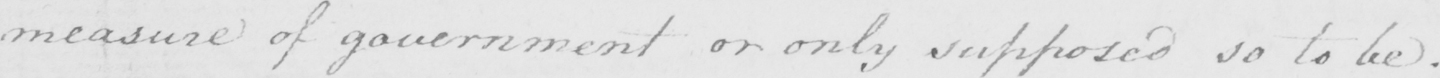Transcribe the text shown in this historical manuscript line. measure of government or only supposed so to be . 